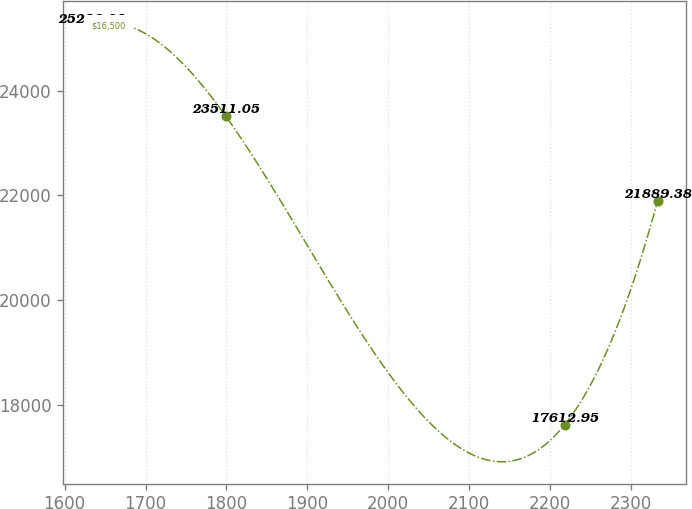Convert chart to OTSL. <chart><loc_0><loc_0><loc_500><loc_500><line_chart><ecel><fcel>$16,500<nl><fcel>1632.96<fcel>25238.2<nl><fcel>1799.27<fcel>23511<nl><fcel>2218.08<fcel>17613<nl><fcel>2333.08<fcel>21889.4<nl></chart> 